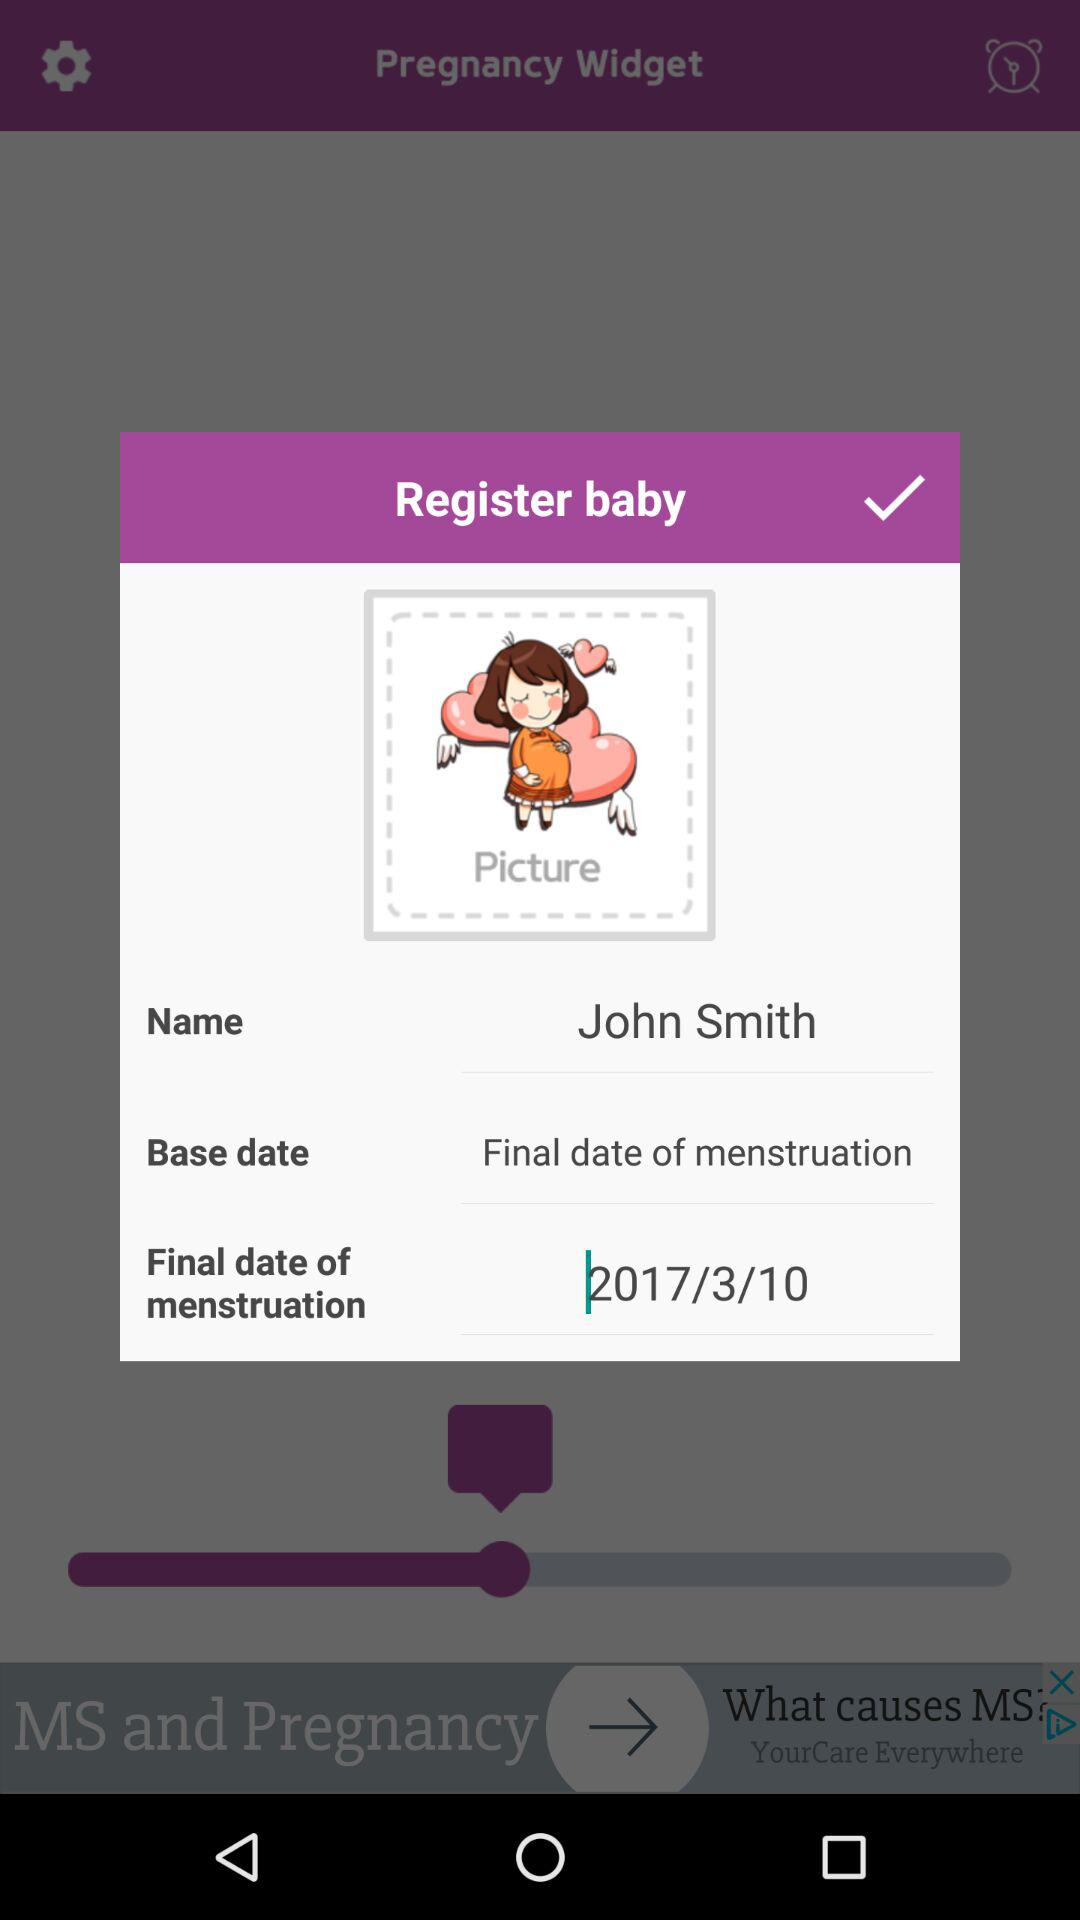What is the name of the application? The name of the application is "Pregnancy Widget". 